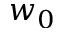Convert formula to latex. <formula><loc_0><loc_0><loc_500><loc_500>w _ { 0 }</formula> 